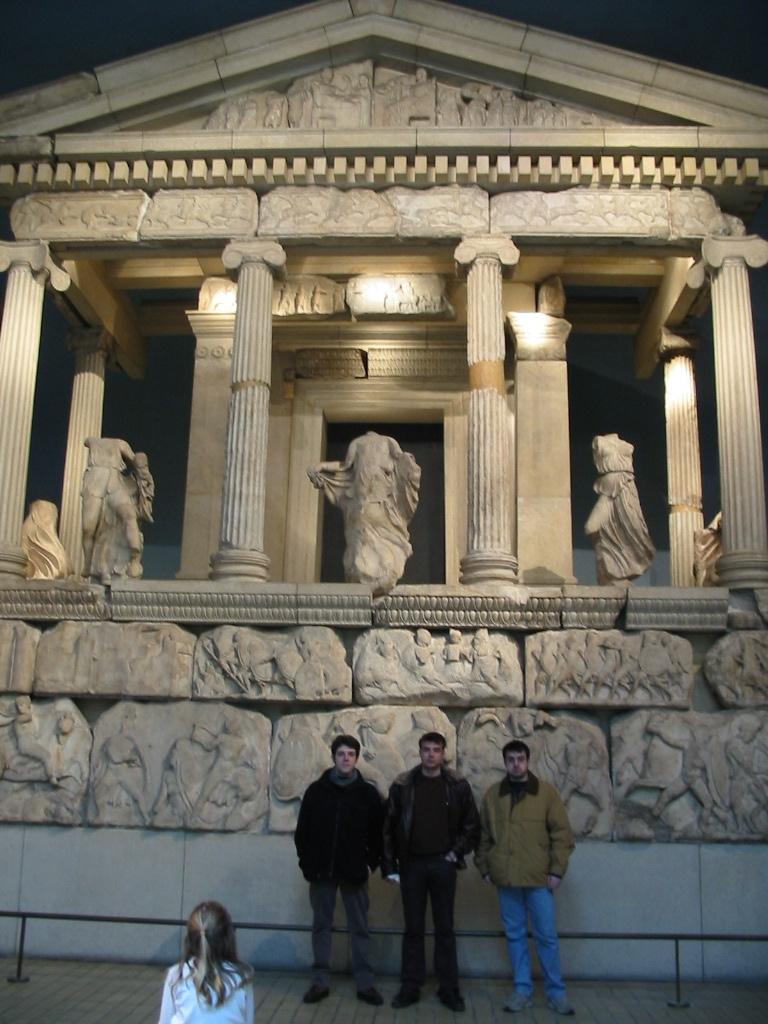How many men are in the image? There are three men standing in the middle of the image. What are the men wearing? The men are wearing coats, trousers, and shoes. What can be seen at the top of the image? There is an old construction visible at the top of the image. What is present within the old construction? There are statues present in the old construction. Can you find a match in the image? There is no match present in the image. What type of picture is hanging on the wall in the image? The image does not show any pictures hanging on the wall. 